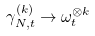Convert formula to latex. <formula><loc_0><loc_0><loc_500><loc_500>\gamma _ { N , t } ^ { ( k ) } \to \omega _ { t } ^ { \otimes k }</formula> 